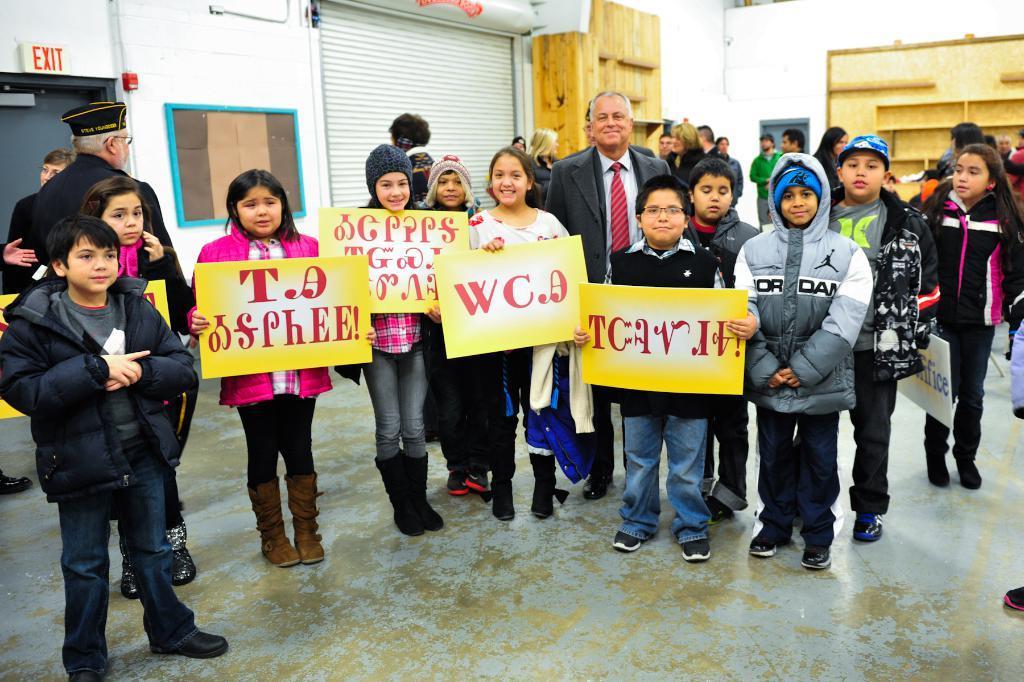Could you give a brief overview of what you see in this image? In the foreground of this image, there are people standing on the floor and holding few boards. In the background, there is a shutter, a board on the wall, a sign board and a wooden shelf on the right. 